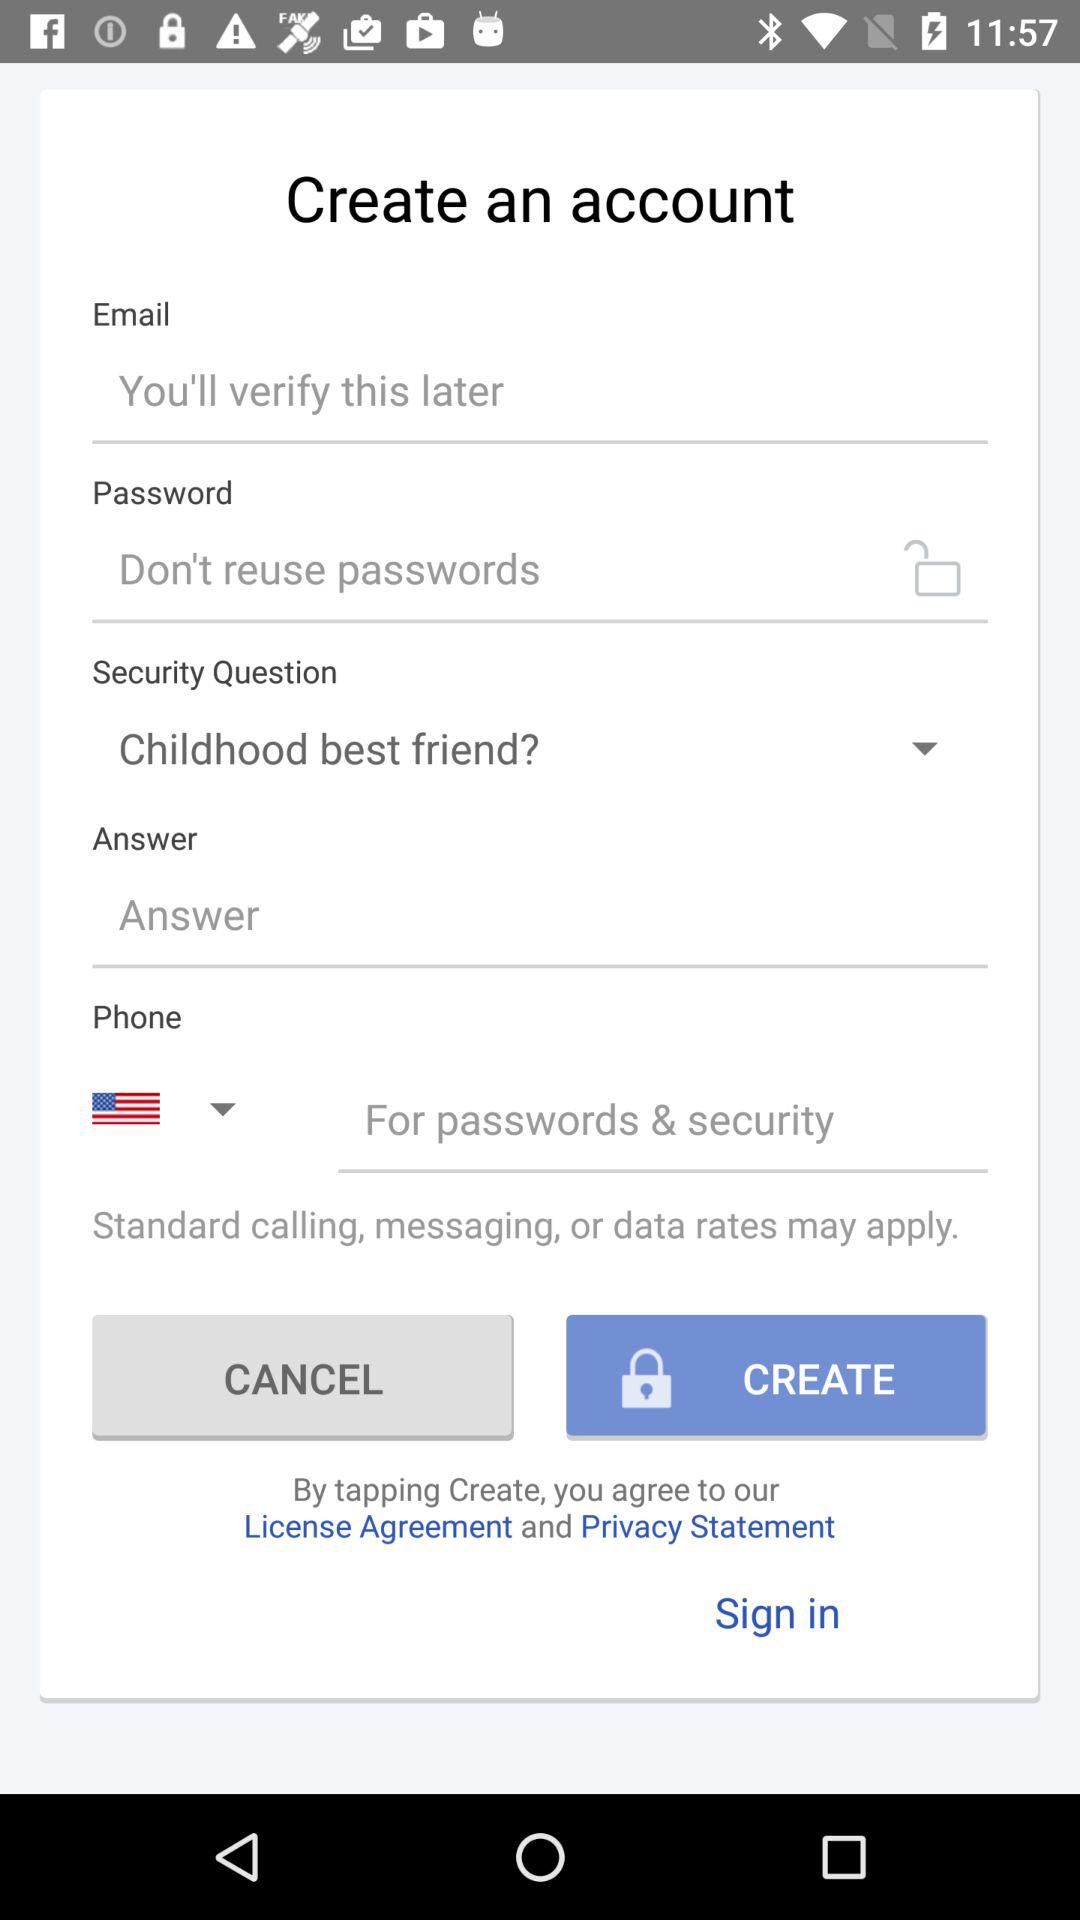How many text inputs are on this page?
Answer the question using a single word or phrase. 4 